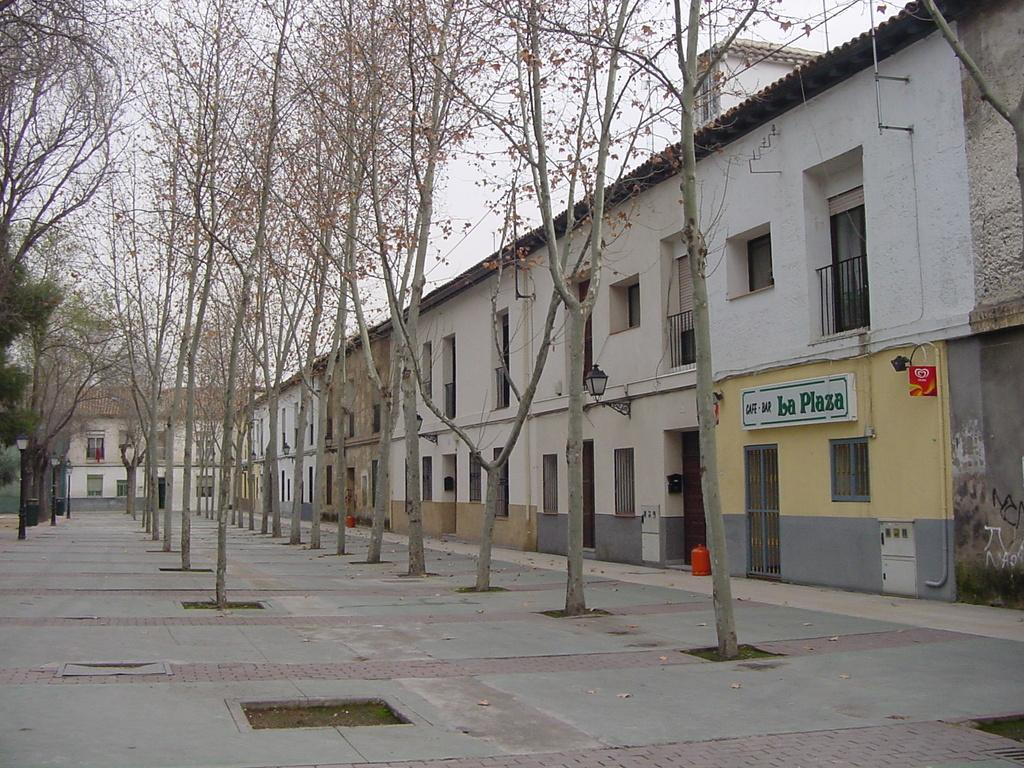What type of structure is depicted in the image? There is a wide building in the image. What features can be observed on the building? The building has many doors and many windows. What is present in front of the building? There are tall trees in between a path in front of the building. Can you see any boats in the image? No, there are no boats present in the image. Are there any people sleeping on the building's roof in the image? No, there is no indication of people sleeping on the building's roof in the image. 